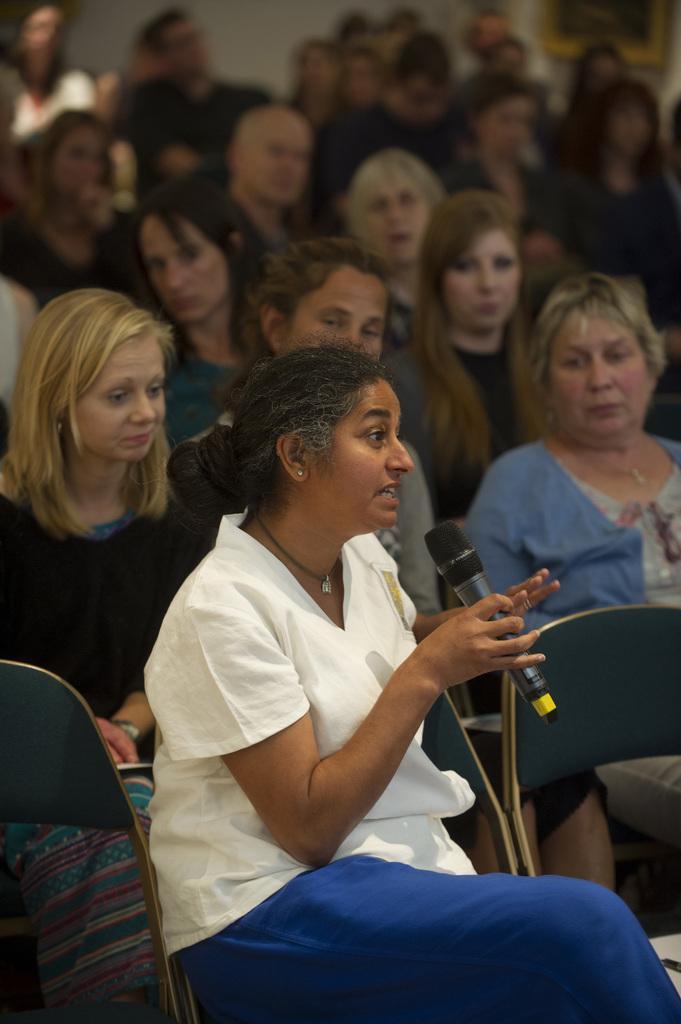Please provide a concise description of this image. It is a meeting,there are a lot of people sitting on the chairs and in the front there is a woman speaking something she is holding a mic in her hand and she is wearing a white and blue dress. 